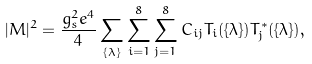Convert formula to latex. <formula><loc_0><loc_0><loc_500><loc_500>| { M } | ^ { 2 } = \frac { g _ { s } ^ { 2 } e ^ { 4 } } { 4 } \sum _ { \{ \lambda \} } \sum _ { i = 1 } ^ { 8 } \sum _ { j = 1 } ^ { 8 } C _ { i j } T _ { i } ( \{ \lambda \} ) T _ { j } ^ { * } ( \{ \lambda \} ) ,</formula> 